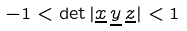Convert formula to latex. <formula><loc_0><loc_0><loc_500><loc_500>- 1 < \det | \underline { x } \, \underline { y } \, \underline { z } | < 1</formula> 